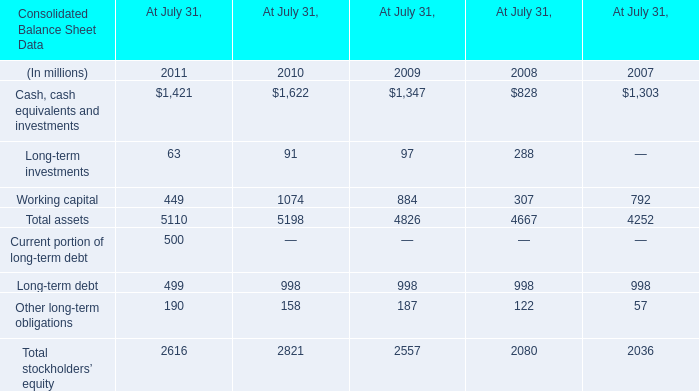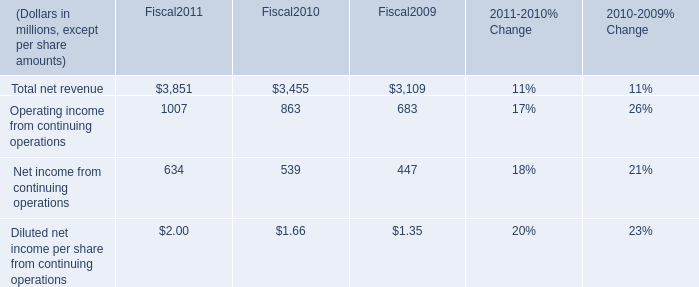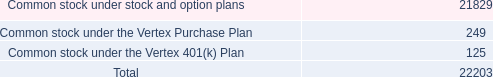What's the sum of Cash, cash equivalents and investments of At July 31, 2009, Operating income from continuing operations of Fiscal2011, and Total assets of At July 31, 2008 ? 
Computations: ((1347.0 + 1007.0) + 4667.0)
Answer: 7021.0. 